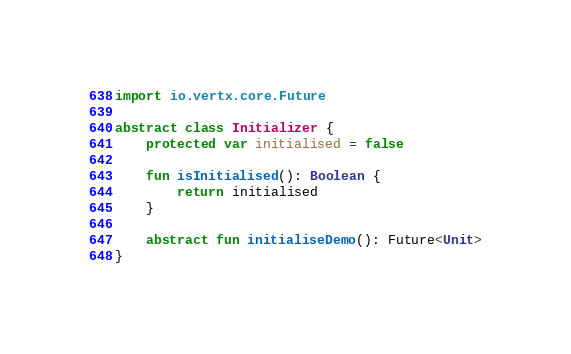<code> <loc_0><loc_0><loc_500><loc_500><_Kotlin_>import io.vertx.core.Future

abstract class Initializer {
    protected var initialised = false

    fun isInitialised(): Boolean {
        return initialised
    }

    abstract fun initialiseDemo(): Future<Unit>
}</code> 